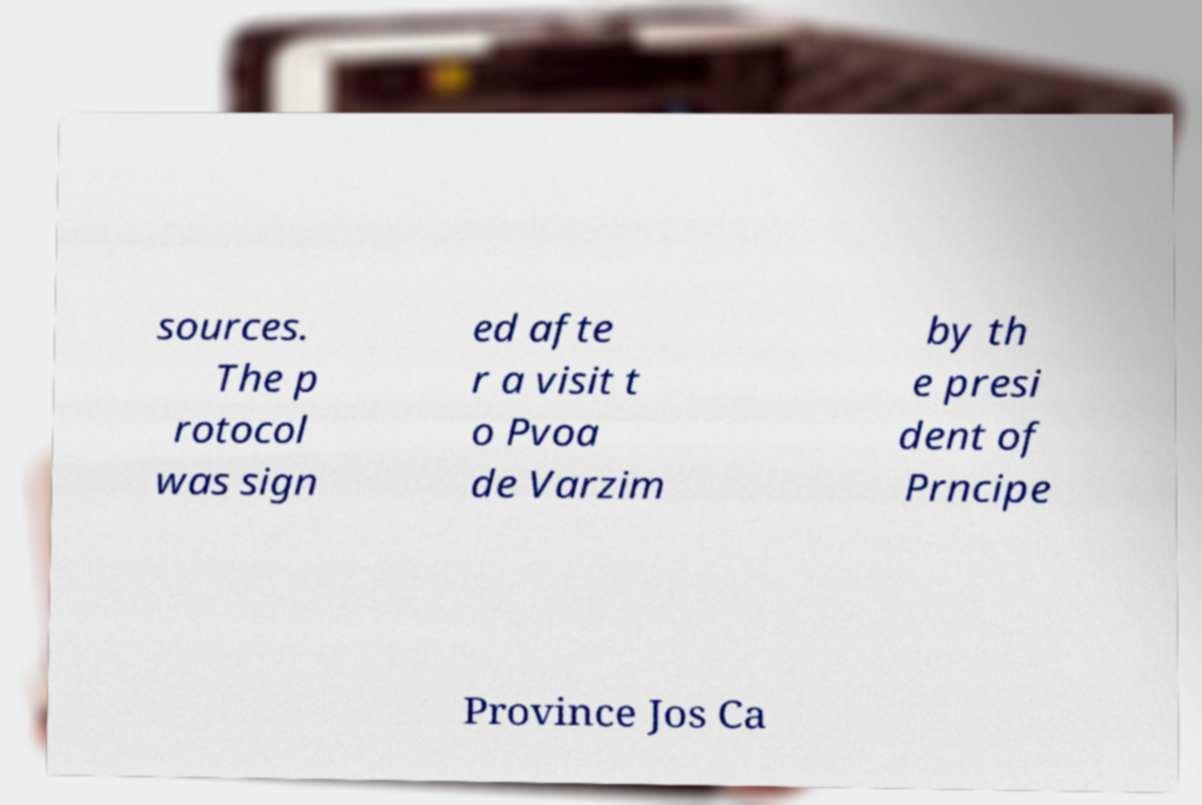There's text embedded in this image that I need extracted. Can you transcribe it verbatim? sources. The p rotocol was sign ed afte r a visit t o Pvoa de Varzim by th e presi dent of Prncipe Province Jos Ca 